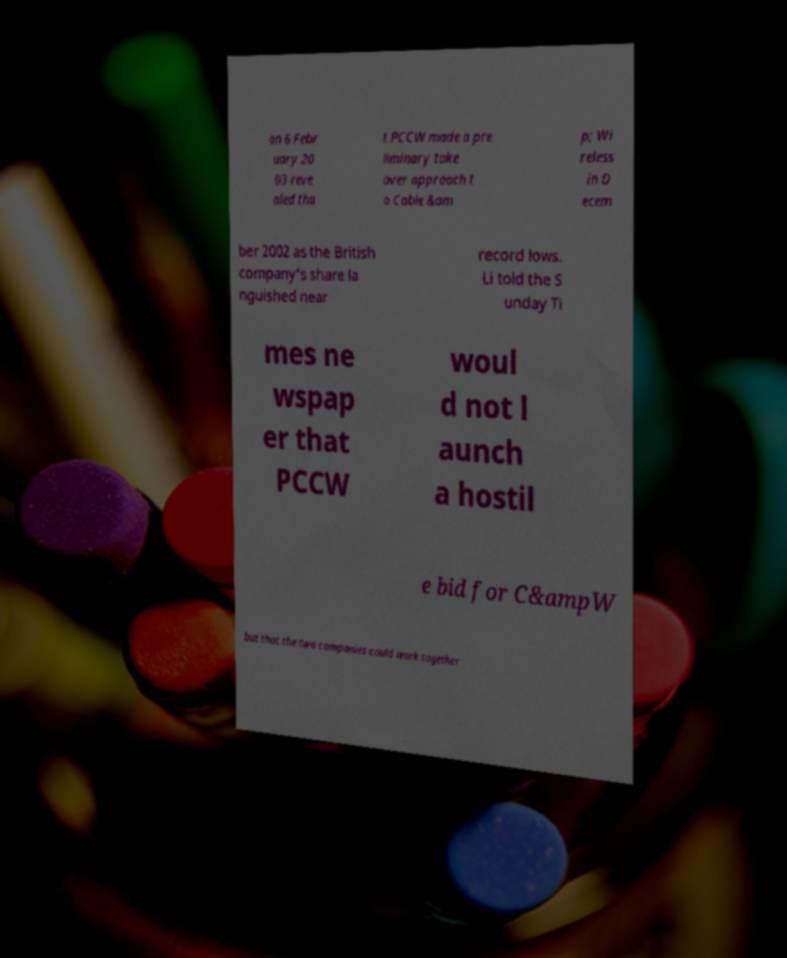Can you read and provide the text displayed in the image?This photo seems to have some interesting text. Can you extract and type it out for me? on 6 Febr uary 20 03 reve aled tha t PCCW made a pre liminary take over approach t o Cable &am p; Wi reless in D ecem ber 2002 as the British company's share la nguished near record lows. Li told the S unday Ti mes ne wspap er that PCCW woul d not l aunch a hostil e bid for C&ampW but that the two companies could work together 